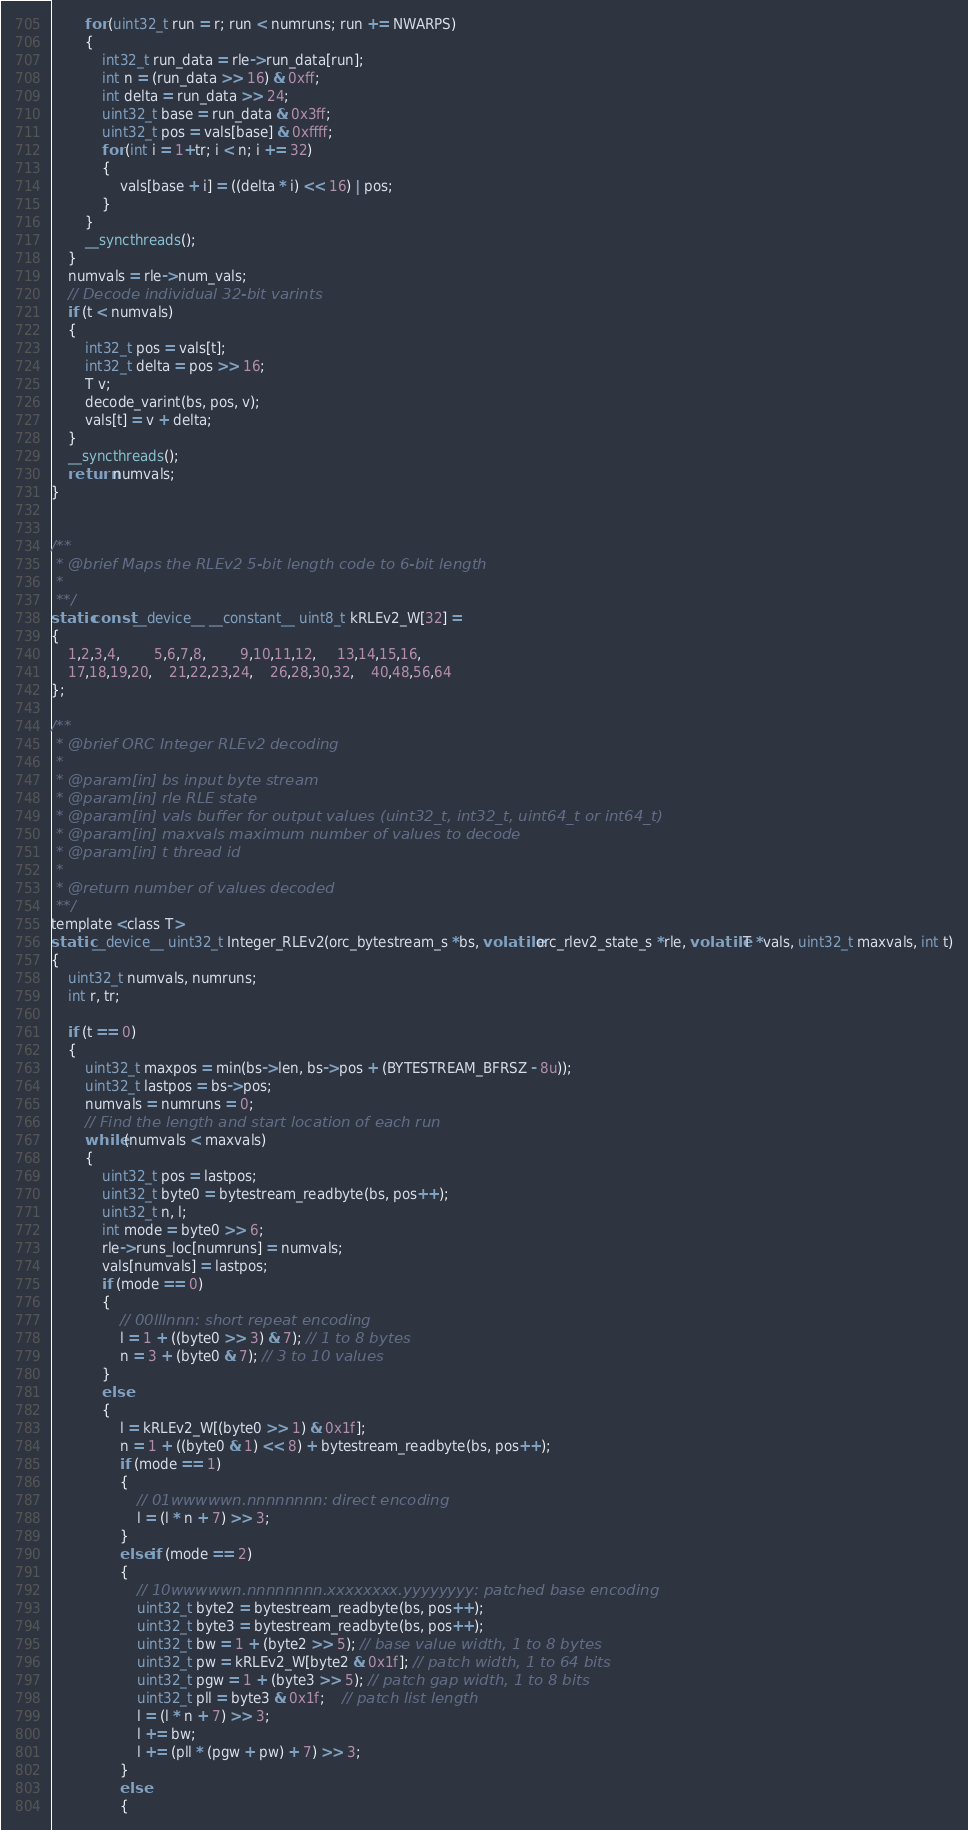<code> <loc_0><loc_0><loc_500><loc_500><_Cuda_>        for (uint32_t run = r; run < numruns; run += NWARPS)
        {
            int32_t run_data = rle->run_data[run];
            int n = (run_data >> 16) & 0xff;
            int delta = run_data >> 24;
            uint32_t base = run_data & 0x3ff;
            uint32_t pos = vals[base] & 0xffff;
            for (int i = 1+tr; i < n; i += 32)
            {
                vals[base + i] = ((delta * i) << 16) | pos;
            }
        }
        __syncthreads();
    }
    numvals = rle->num_vals;
    // Decode individual 32-bit varints
    if (t < numvals)
    {
        int32_t pos = vals[t];
        int32_t delta = pos >> 16;
        T v;
        decode_varint(bs, pos, v);
        vals[t] = v + delta;
    }
    __syncthreads();
    return numvals;
}


/**
 * @brief Maps the RLEv2 5-bit length code to 6-bit length
 *
 **/
static const __device__ __constant__ uint8_t kRLEv2_W[32] =
{
    1,2,3,4,        5,6,7,8,        9,10,11,12,     13,14,15,16,
    17,18,19,20,    21,22,23,24,    26,28,30,32,    40,48,56,64
};

/**
 * @brief ORC Integer RLEv2 decoding
 *
 * @param[in] bs input byte stream
 * @param[in] rle RLE state
 * @param[in] vals buffer for output values (uint32_t, int32_t, uint64_t or int64_t)
 * @param[in] maxvals maximum number of values to decode
 * @param[in] t thread id
 *
 * @return number of values decoded
 **/
template <class T>
static __device__ uint32_t Integer_RLEv2(orc_bytestream_s *bs, volatile orc_rlev2_state_s *rle, volatile T *vals, uint32_t maxvals, int t)
{
    uint32_t numvals, numruns;
    int r, tr;

    if (t == 0)
    {
        uint32_t maxpos = min(bs->len, bs->pos + (BYTESTREAM_BFRSZ - 8u));
        uint32_t lastpos = bs->pos;
        numvals = numruns = 0;
        // Find the length and start location of each run
        while (numvals < maxvals)
        {
            uint32_t pos = lastpos;
            uint32_t byte0 = bytestream_readbyte(bs, pos++);
            uint32_t n, l;
            int mode = byte0 >> 6;
            rle->runs_loc[numruns] = numvals;
            vals[numvals] = lastpos;           
            if (mode == 0)
            {
                // 00lllnnn: short repeat encoding
                l = 1 + ((byte0 >> 3) & 7); // 1 to 8 bytes
                n = 3 + (byte0 & 7); // 3 to 10 values
            }
            else
            {
                l = kRLEv2_W[(byte0 >> 1) & 0x1f];
                n = 1 + ((byte0 & 1) << 8) + bytestream_readbyte(bs, pos++);
                if (mode == 1)
                {
                    // 01wwwwwn.nnnnnnnn: direct encoding
                    l = (l * n + 7) >> 3;
                }
                else if (mode == 2)
                {
                    // 10wwwwwn.nnnnnnnn.xxxxxxxx.yyyyyyyy: patched base encoding
                    uint32_t byte2 = bytestream_readbyte(bs, pos++);
                    uint32_t byte3 = bytestream_readbyte(bs, pos++);
                    uint32_t bw = 1 + (byte2 >> 5); // base value width, 1 to 8 bytes
                    uint32_t pw = kRLEv2_W[byte2 & 0x1f]; // patch width, 1 to 64 bits
                    uint32_t pgw = 1 + (byte3 >> 5); // patch gap width, 1 to 8 bits
                    uint32_t pll = byte3 & 0x1f;    // patch list length
                    l = (l * n + 7) >> 3;
                    l += bw;
                    l += (pll * (pgw + pw) + 7) >> 3;
                }
                else
                {</code> 